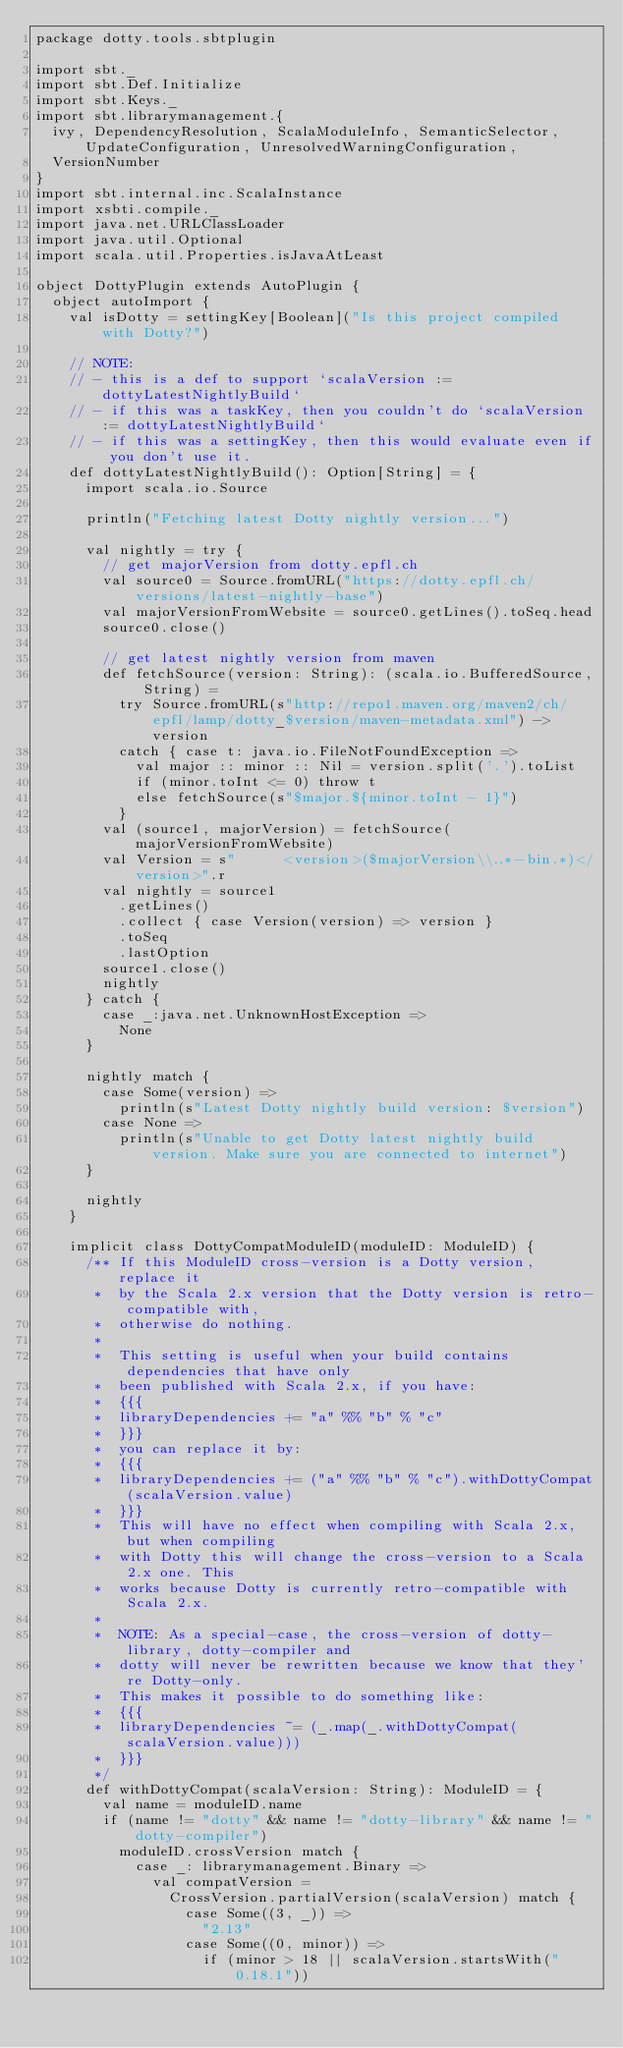Convert code to text. <code><loc_0><loc_0><loc_500><loc_500><_Scala_>package dotty.tools.sbtplugin

import sbt._
import sbt.Def.Initialize
import sbt.Keys._
import sbt.librarymanagement.{
  ivy, DependencyResolution, ScalaModuleInfo, SemanticSelector, UpdateConfiguration, UnresolvedWarningConfiguration,
  VersionNumber
}
import sbt.internal.inc.ScalaInstance
import xsbti.compile._
import java.net.URLClassLoader
import java.util.Optional
import scala.util.Properties.isJavaAtLeast

object DottyPlugin extends AutoPlugin {
  object autoImport {
    val isDotty = settingKey[Boolean]("Is this project compiled with Dotty?")

    // NOTE:
    // - this is a def to support `scalaVersion := dottyLatestNightlyBuild`
    // - if this was a taskKey, then you couldn't do `scalaVersion := dottyLatestNightlyBuild`
    // - if this was a settingKey, then this would evaluate even if you don't use it.
    def dottyLatestNightlyBuild(): Option[String] = {
      import scala.io.Source

      println("Fetching latest Dotty nightly version...")

      val nightly = try {
        // get majorVersion from dotty.epfl.ch
        val source0 = Source.fromURL("https://dotty.epfl.ch/versions/latest-nightly-base")
        val majorVersionFromWebsite = source0.getLines().toSeq.head
        source0.close()

        // get latest nightly version from maven
        def fetchSource(version: String): (scala.io.BufferedSource, String) =
          try Source.fromURL(s"http://repo1.maven.org/maven2/ch/epfl/lamp/dotty_$version/maven-metadata.xml") -> version
          catch { case t: java.io.FileNotFoundException =>
            val major :: minor :: Nil = version.split('.').toList
            if (minor.toInt <= 0) throw t
            else fetchSource(s"$major.${minor.toInt - 1}")
          }
        val (source1, majorVersion) = fetchSource(majorVersionFromWebsite)
        val Version = s"      <version>($majorVersion\\..*-bin.*)</version>".r
        val nightly = source1
          .getLines()
          .collect { case Version(version) => version }
          .toSeq
          .lastOption
        source1.close()
        nightly
      } catch {
        case _:java.net.UnknownHostException =>
          None
      }

      nightly match {
        case Some(version) =>
          println(s"Latest Dotty nightly build version: $version")
        case None =>
          println(s"Unable to get Dotty latest nightly build version. Make sure you are connected to internet")
      }

      nightly
    }

    implicit class DottyCompatModuleID(moduleID: ModuleID) {
      /** If this ModuleID cross-version is a Dotty version, replace it
       *  by the Scala 2.x version that the Dotty version is retro-compatible with,
       *  otherwise do nothing.
       *
       *  This setting is useful when your build contains dependencies that have only
       *  been published with Scala 2.x, if you have:
       *  {{{
       *  libraryDependencies += "a" %% "b" % "c"
       *  }}}
       *  you can replace it by:
       *  {{{
       *  libraryDependencies += ("a" %% "b" % "c").withDottyCompat(scalaVersion.value)
       *  }}}
       *  This will have no effect when compiling with Scala 2.x, but when compiling
       *  with Dotty this will change the cross-version to a Scala 2.x one. This
       *  works because Dotty is currently retro-compatible with Scala 2.x.
       *
       *  NOTE: As a special-case, the cross-version of dotty-library, dotty-compiler and
       *  dotty will never be rewritten because we know that they're Dotty-only.
       *  This makes it possible to do something like:
       *  {{{
       *  libraryDependencies ~= (_.map(_.withDottyCompat(scalaVersion.value)))
       *  }}}
       */
      def withDottyCompat(scalaVersion: String): ModuleID = {
        val name = moduleID.name
        if (name != "dotty" && name != "dotty-library" && name != "dotty-compiler")
          moduleID.crossVersion match {
            case _: librarymanagement.Binary =>
              val compatVersion =
                CrossVersion.partialVersion(scalaVersion) match {
                  case Some((3, _)) =>
                    "2.13"
                  case Some((0, minor)) =>
                    if (minor > 18 || scalaVersion.startsWith("0.18.1"))</code> 